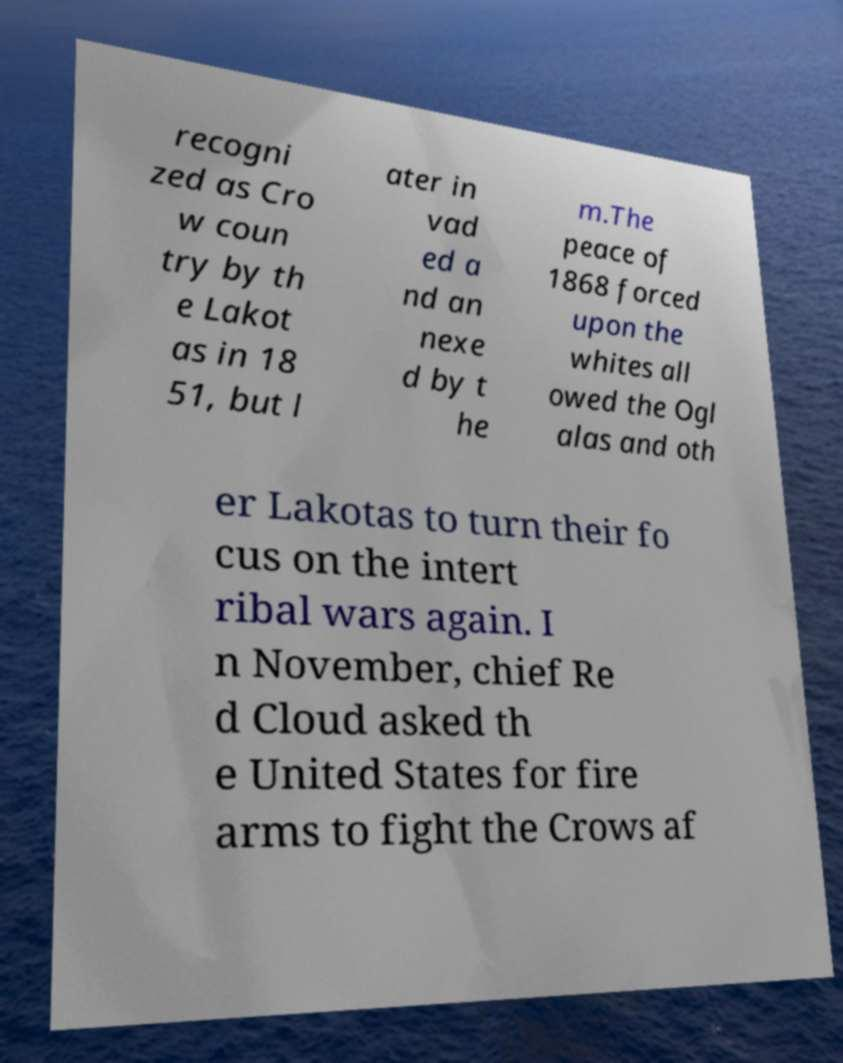I need the written content from this picture converted into text. Can you do that? recogni zed as Cro w coun try by th e Lakot as in 18 51, but l ater in vad ed a nd an nexe d by t he m.The peace of 1868 forced upon the whites all owed the Ogl alas and oth er Lakotas to turn their fo cus on the intert ribal wars again. I n November, chief Re d Cloud asked th e United States for fire arms to fight the Crows af 